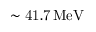<formula> <loc_0><loc_0><loc_500><loc_500>\sim 4 1 . 7 \, M e V</formula> 